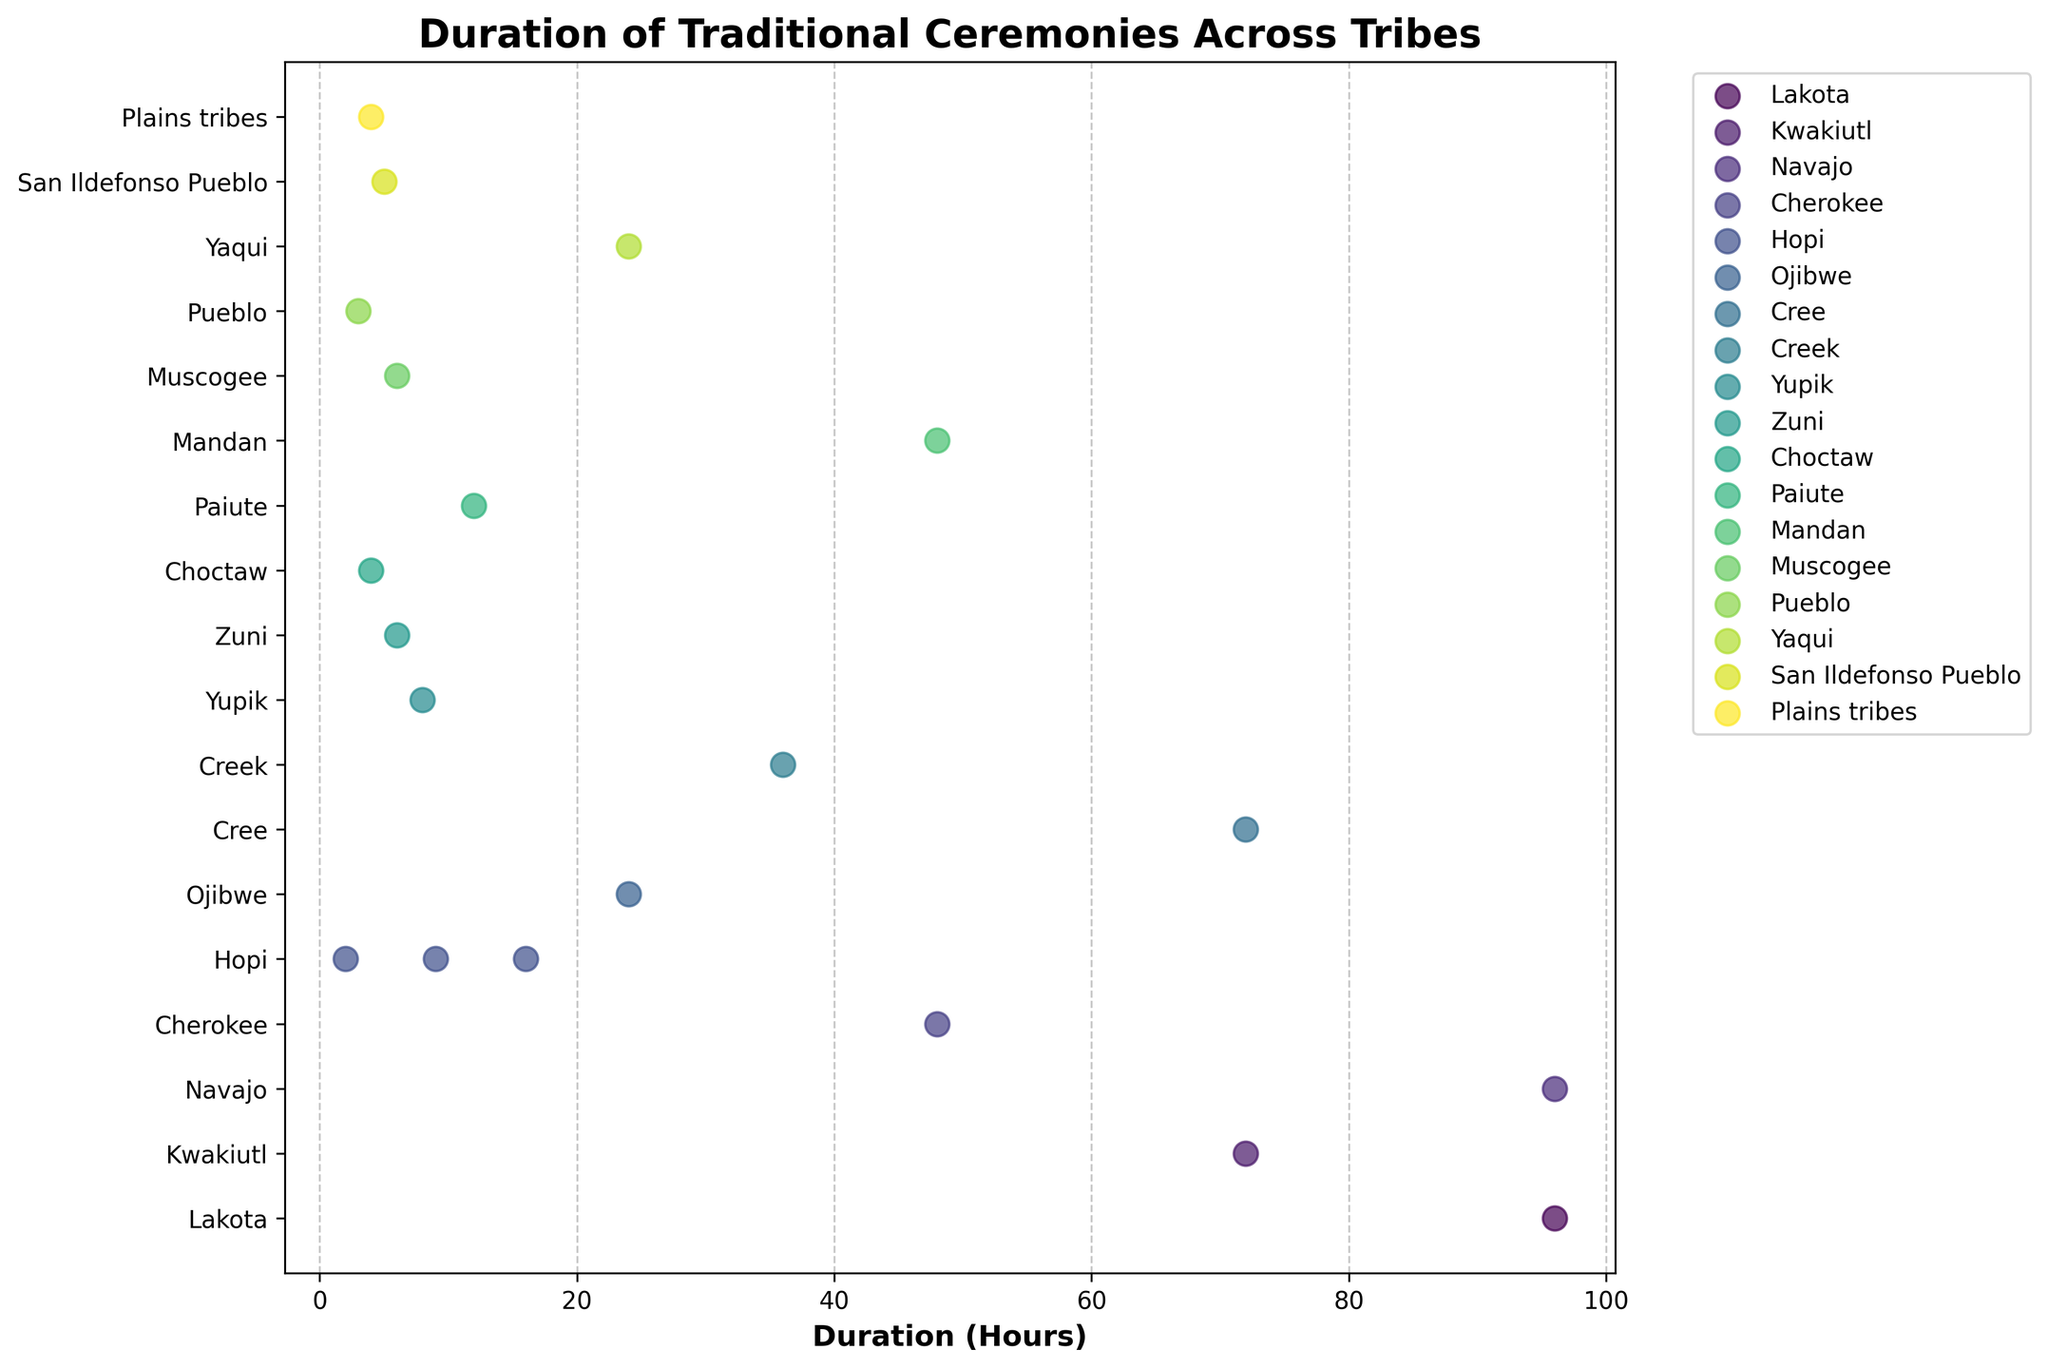Which tribe has the longest duration for its ceremony? By looking at the position of the data points on the x-axis, the longest duration is 96 hours, and the corresponding tribe label is Lakota and Navajo.
Answer: Lakota and Navajo How many ceremonies have a duration of less than 10 hours? Count the number of data points positioned between 0 and 10 on the x-axis. These are from the tribes Hopi (3 points), Zuni, Choctaw, San Ildefonso Pueblo, and Pueblo.
Answer: 7 Which tribes have ceremonies that last exactly 24 hours? Identify the data points at the 24-hour mark and check their corresponding tribe labels.
Answer: Ojibwe and Yaqui What is the range of durations for Hopi ceremonies? The lowest duration for Hopi is 2 hours (Butterfly Dance) and the highest duration is 16 hours (Hopi Snake Dance).
Answer: 2 to 16 hours How many unique tribes are represented in the plot? Count the number of unique tribe labels on the y-axis.
Answer: 16 Do any tribes have more than one ceremony listed? If yes, which ones? Check for tribes with multiple data points in the plot. Hopi is one such tribe with 3 ceremonies listed (Butterfly Dance, Hopi Snake Dance, and Bean Dance).
Answer: Hopi Which ceremony has the shortest duration? By looking at the leftmost position on the x-axis, the shortest duration is 2 hours, corresponding to the Butterfly Dance of the Hopi tribe.
Answer: Butterfly Dance (Hopi) What's the total duration of all ceremonies from the Paiute and Mandan tribes combined? The Paiute have the Ghost Dance (12 hrs), and the Mandan have the Medicine Dance (48 hrs). The total is 12 + 48 = 60 hours.
Answer: 60 hours Which tribe has both the Bean Dance and the Butterfly Dance? Identify the tribe markers next to both the Bean Dance and Butterfly Dance. Both belong to the Hopi tribe.
Answer: Hopi Are there more ceremonies with a duration of 48 hours or more than those with less? Count the ceremonies with durations >= 48 hours (5 points) and those with durations < 48 hours (14 points).
Answer: Less than 48 hours 